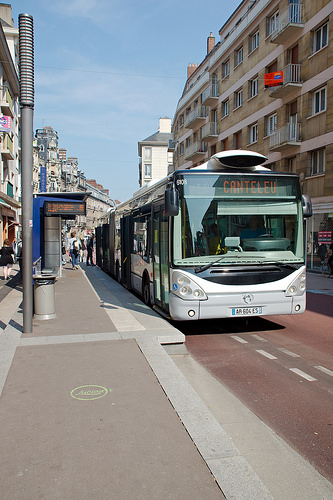<image>
Can you confirm if the bus is on the building? No. The bus is not positioned on the building. They may be near each other, but the bus is not supported by or resting on top of the building. 